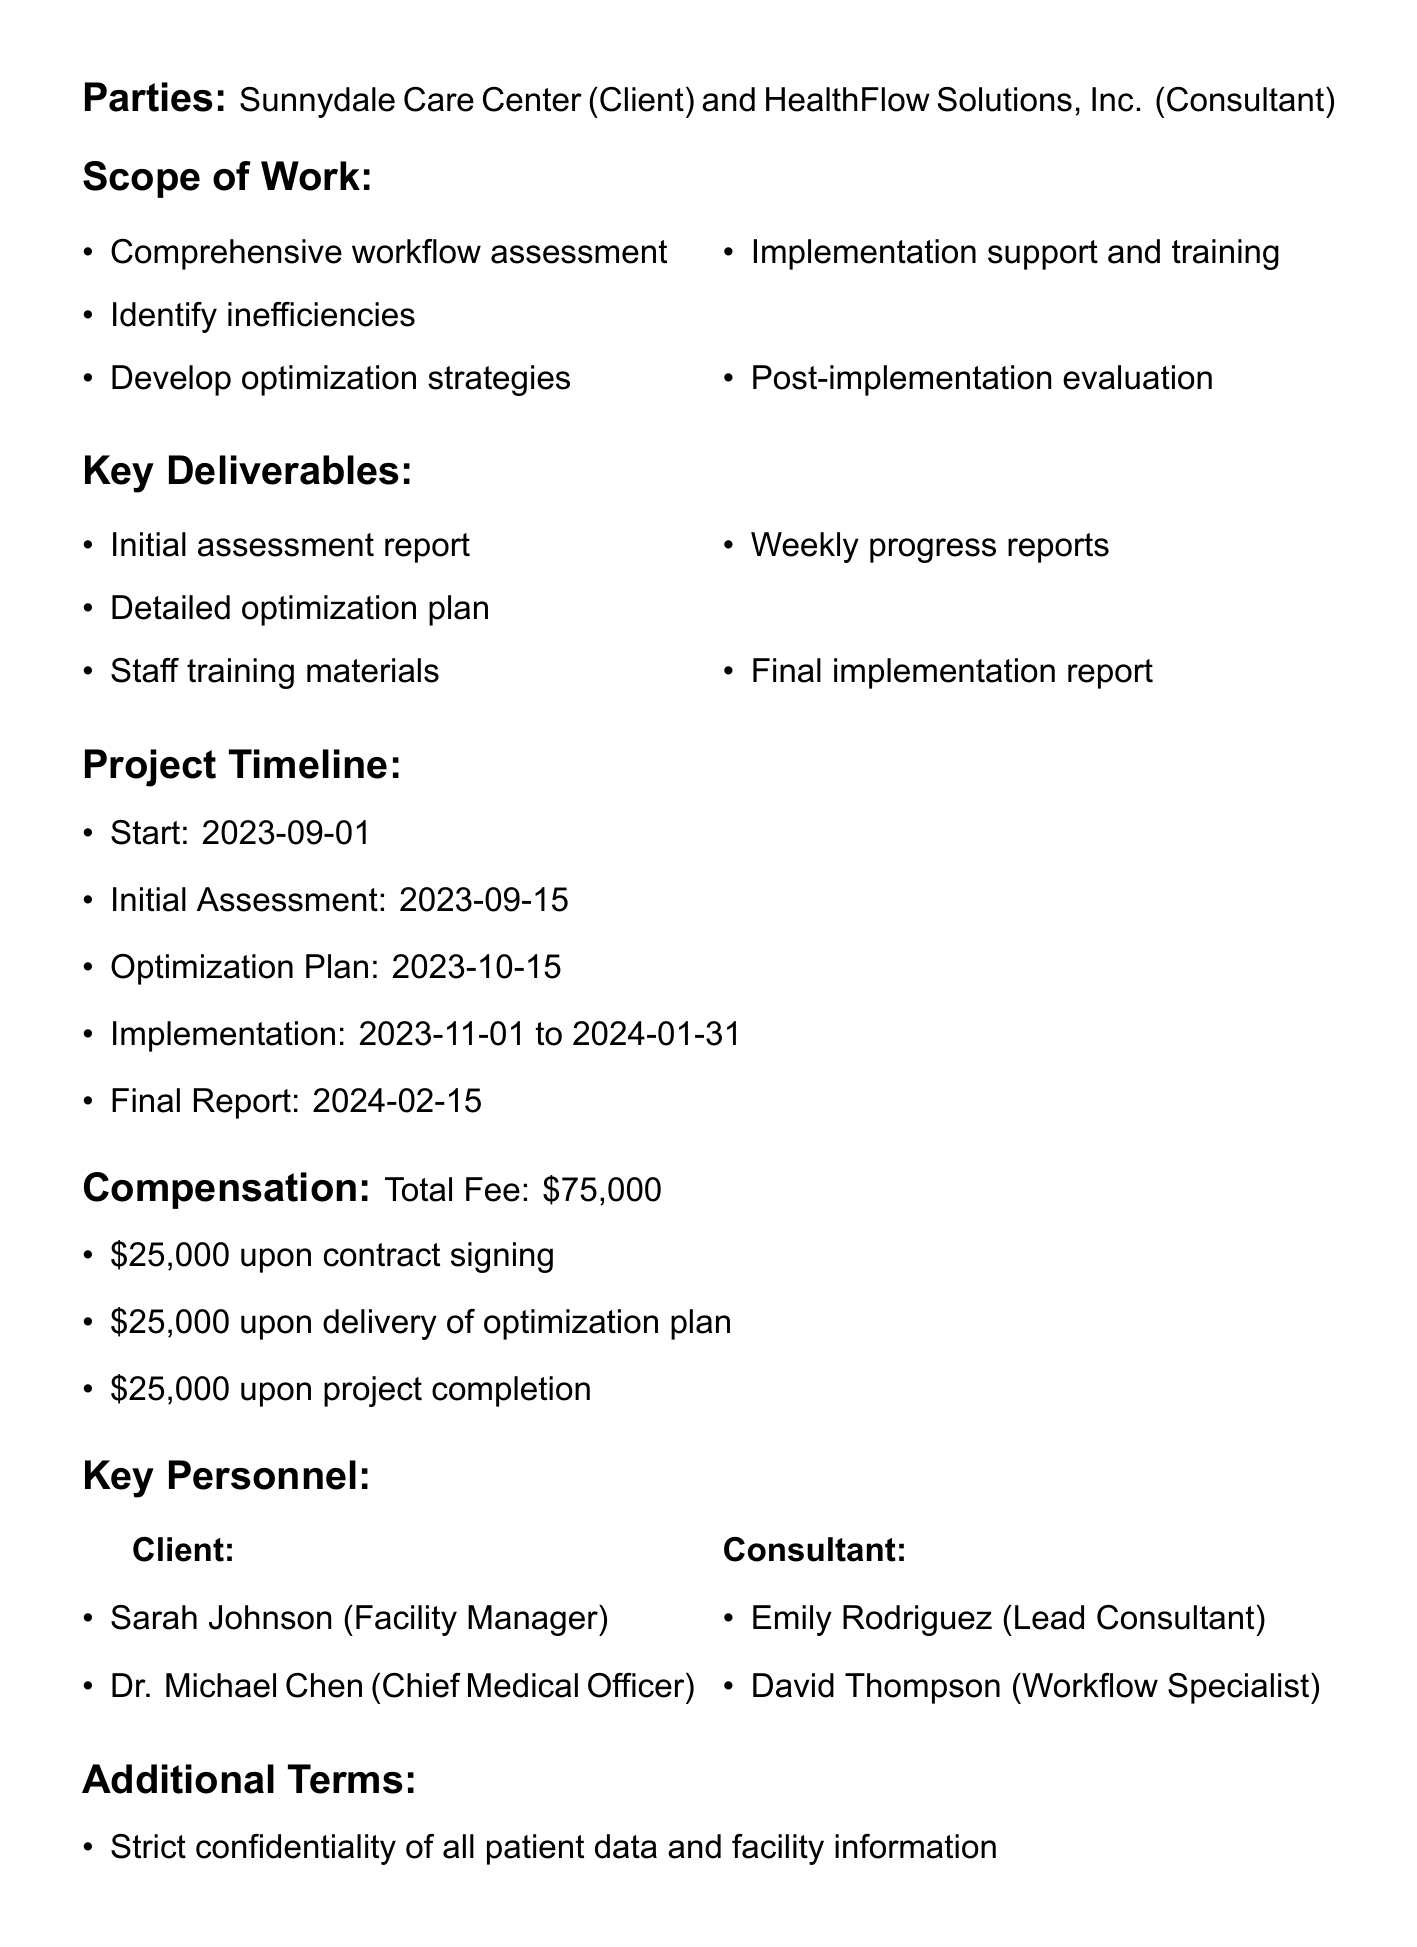What is the title of the contract? The title of the contract appears prominently at the beginning of the document, which is "Consulting Services Agreement for Workflow Optimization."
Answer: Consulting Services Agreement for Workflow Optimization Who is the client in the agreement? The client is one of the parties specified in the document under the parties section, which mentions "Sunnydale Care Center."
Answer: Sunnydale Care Center What is the total fee for the consulting services? The total fee is explicitly stated in the compensation section of the document, which is "$75,000."
Answer: $75,000 When does the project start? The project start date is listed in the timeline section of the document as "2023-09-01."
Answer: 2023-09-01 What is one performance metric mentioned in the quality assurance section? The document outlines specific performance metrics in the quality assurance section, such as "20% reduction in patient wait times."
Answer: 20% reduction in patient wait times How many payment installments are specified in the compensation section? The compensation section lists the payment schedule, detailing three installments to be paid at different stages of the project.
Answer: 3 What is the hourly rate for additional services? The document mentions the hourly rate for additional services in the additional services section, which is "$200 per hour."
Answer: $200 per hour What type of meetings are scheduled for progress review? The document states that there will be "Bi-weekly progress review meetings" in the quality assurance section.
Answer: Bi-weekly progress review meetings How long is the notice period for contract termination? The termination clause in the document specifies that either party may terminate the contract with "30 days written notice."
Answer: 30 days written notice 